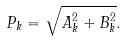Convert formula to latex. <formula><loc_0><loc_0><loc_500><loc_500>P _ { k } = \sqrt { A _ { k } ^ { 2 } + B _ { k } ^ { 2 } } .</formula> 